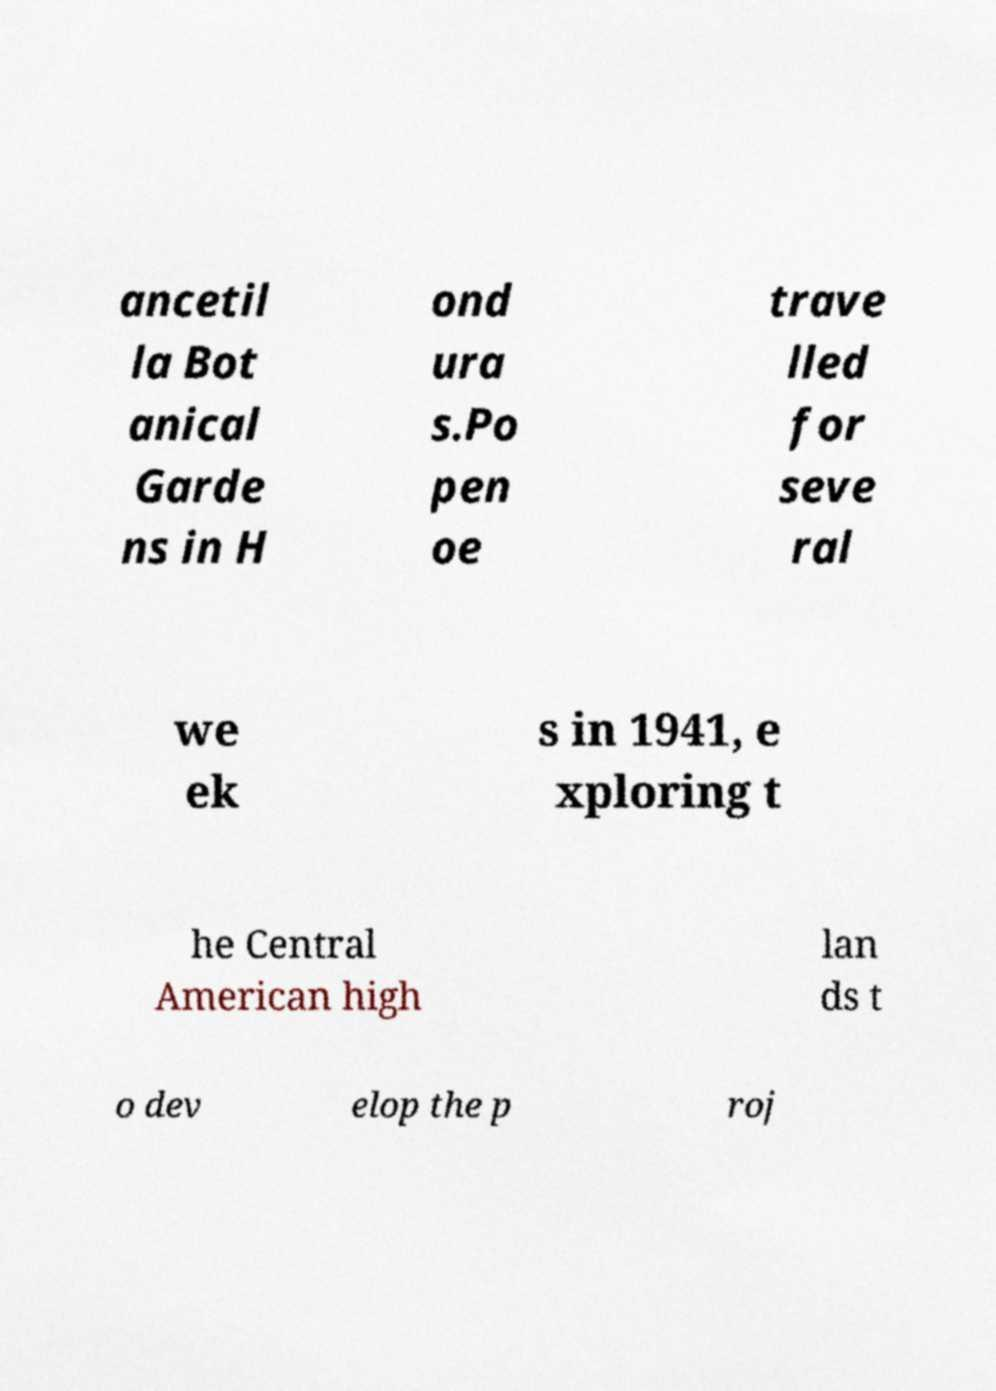Could you extract and type out the text from this image? ancetil la Bot anical Garde ns in H ond ura s.Po pen oe trave lled for seve ral we ek s in 1941, e xploring t he Central American high lan ds t o dev elop the p roj 